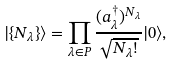Convert formula to latex. <formula><loc_0><loc_0><loc_500><loc_500>| \{ N _ { \lambda } \} \rangle = \prod _ { \lambda \in P } \frac { ( a _ { \lambda } ^ { \dagger } ) ^ { N _ { \lambda } } } { \sqrt { N _ { \lambda } ! } } | 0 \rangle ,</formula> 